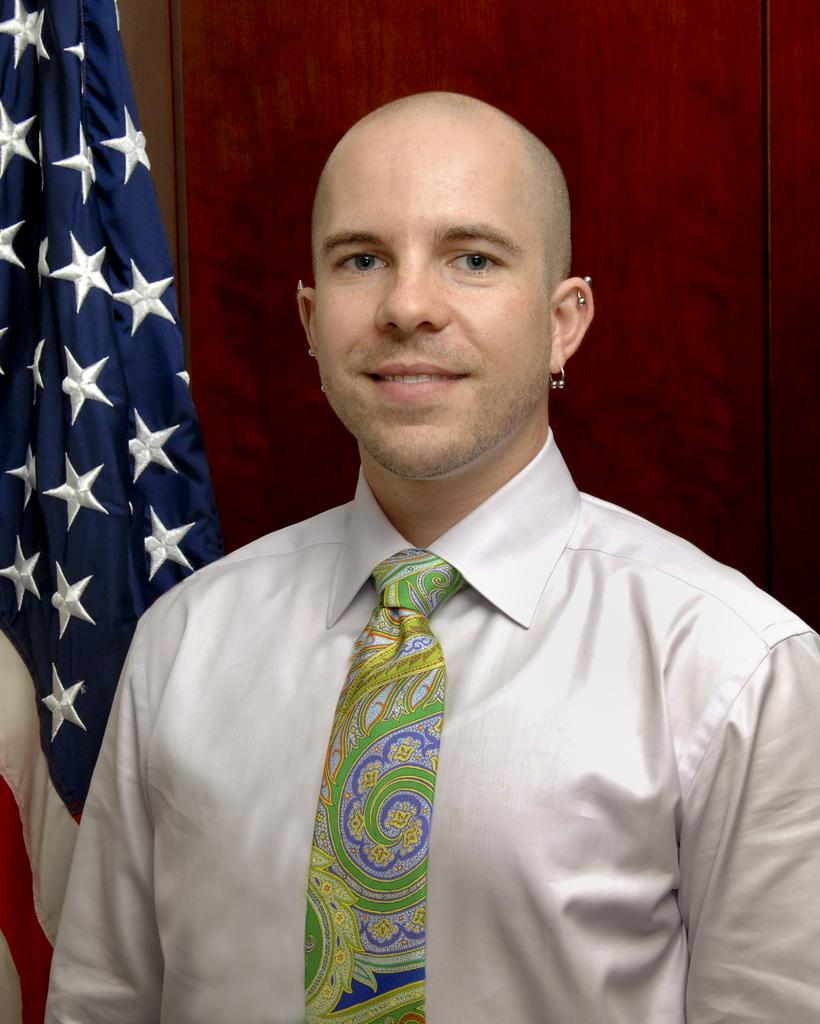What is the main subject of the image? There is a person in the image. Can you describe the person's attire? The person is wearing a shirt and tie. What is the person's facial expression? The person is smiling. What can be seen in the background of the image? There is a red colored surface and a flag in the background of the image. What colors are present on the flag? The flag has white, red, and blue colors. How many pets are visible in the image? There are no pets present in the image. What is the acoustic quality of the person's voice in the image? The image is a still photograph and does not capture any sound or acoustics. 